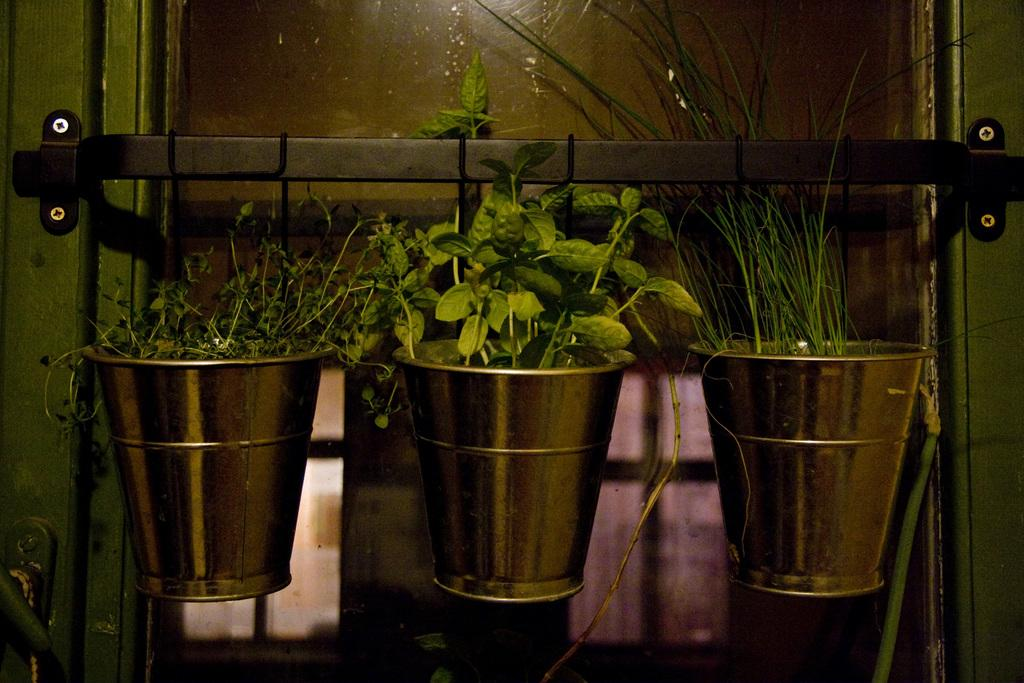What objects are located in the center of the picture? There are buckets, plants, grass, a window, and an iron bar in the center of the picture. What type of plants are present in the picture? The plants in the picture are not specified, but they are located in the center of the picture. What is the purpose of the iron bar in the picture? The purpose of the iron bar in the picture is not specified, but it is located in the center of the picture. What can be seen through the window in the picture? The facts provided do not specify what can be seen through the window in the picture. What color is the crayon used to draw on the locket in the picture? There is no crayon or locket present in the picture. 